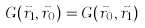<formula> <loc_0><loc_0><loc_500><loc_500>G ( \vec { r } _ { 1 } , \vec { r } _ { 0 } ) = G ( \vec { r } _ { 0 } , \vec { r } _ { 1 } )</formula> 